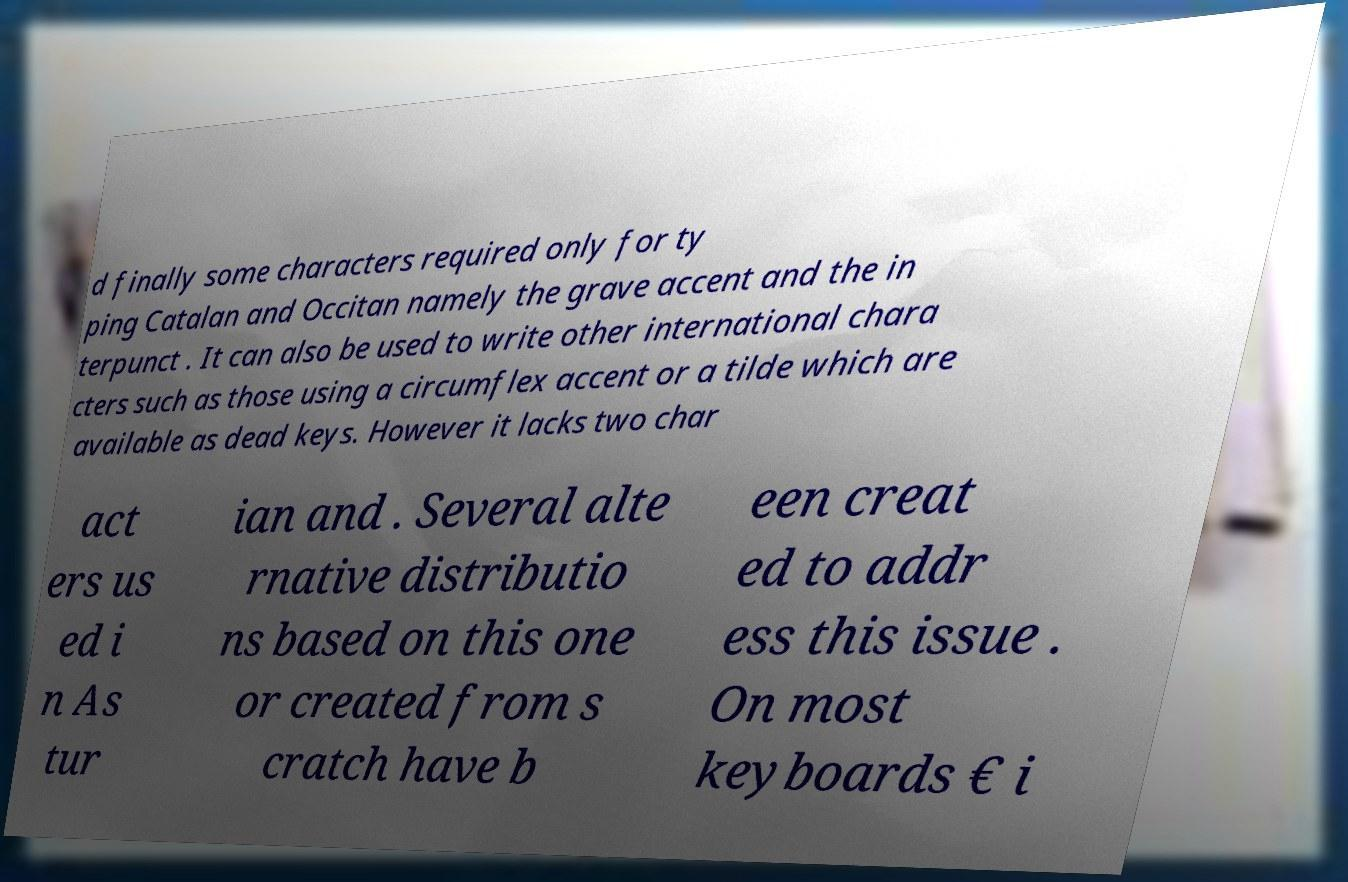Please identify and transcribe the text found in this image. d finally some characters required only for ty ping Catalan and Occitan namely the grave accent and the in terpunct . It can also be used to write other international chara cters such as those using a circumflex accent or a tilde which are available as dead keys. However it lacks two char act ers us ed i n As tur ian and . Several alte rnative distributio ns based on this one or created from s cratch have b een creat ed to addr ess this issue . On most keyboards € i 